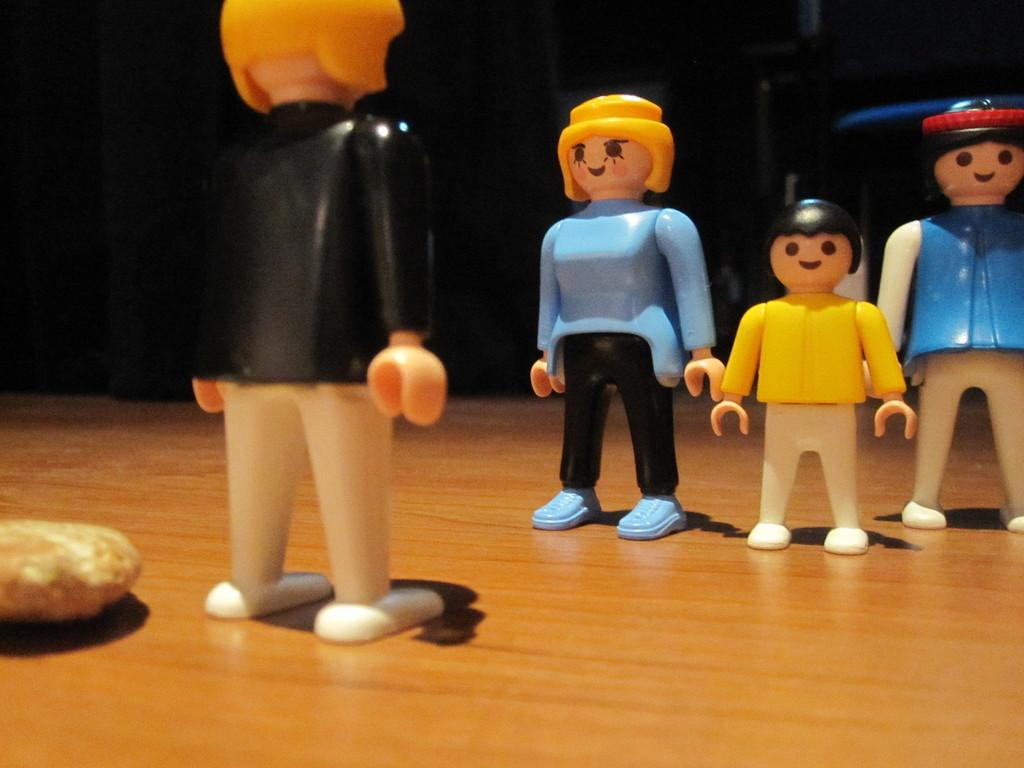What objects are present in the image? There are toys in the image. What type of surface are the toys placed on? The toys are on a wooden surface. What arithmetic problem can be solved using the toys in the image? There is no arithmetic problem present in the image, as it only features toys on a wooden surface. 